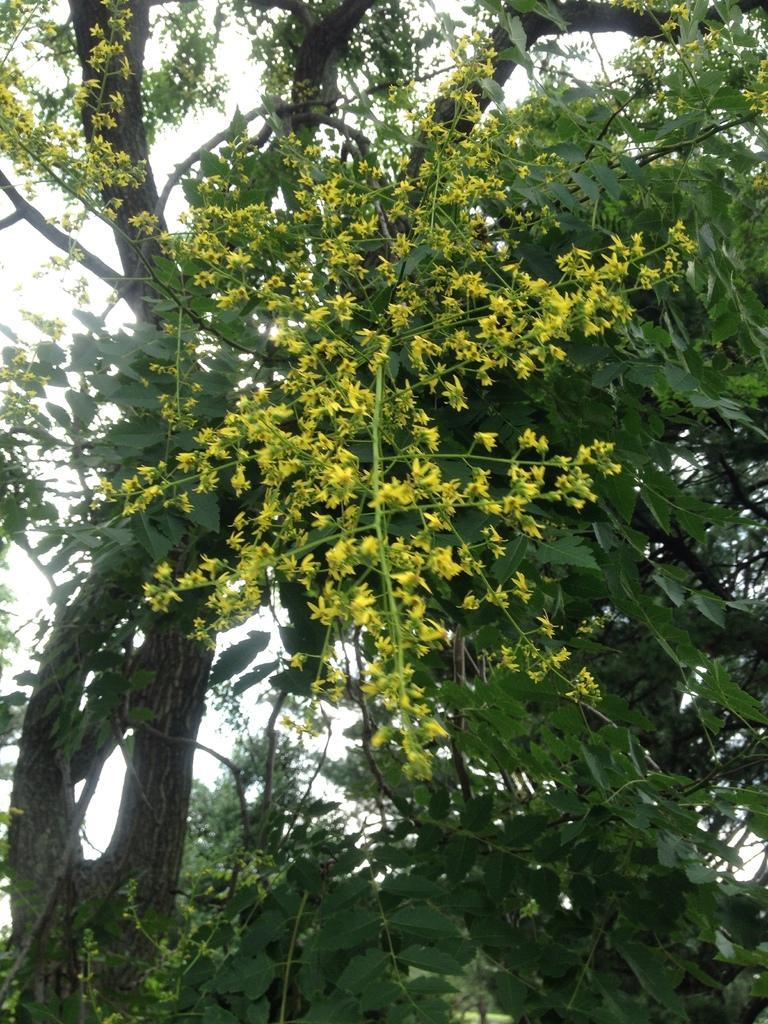Could you give a brief overview of what you see in this image? In the picture we can see a tree with leaves and some parts of the sky from the leaves. 